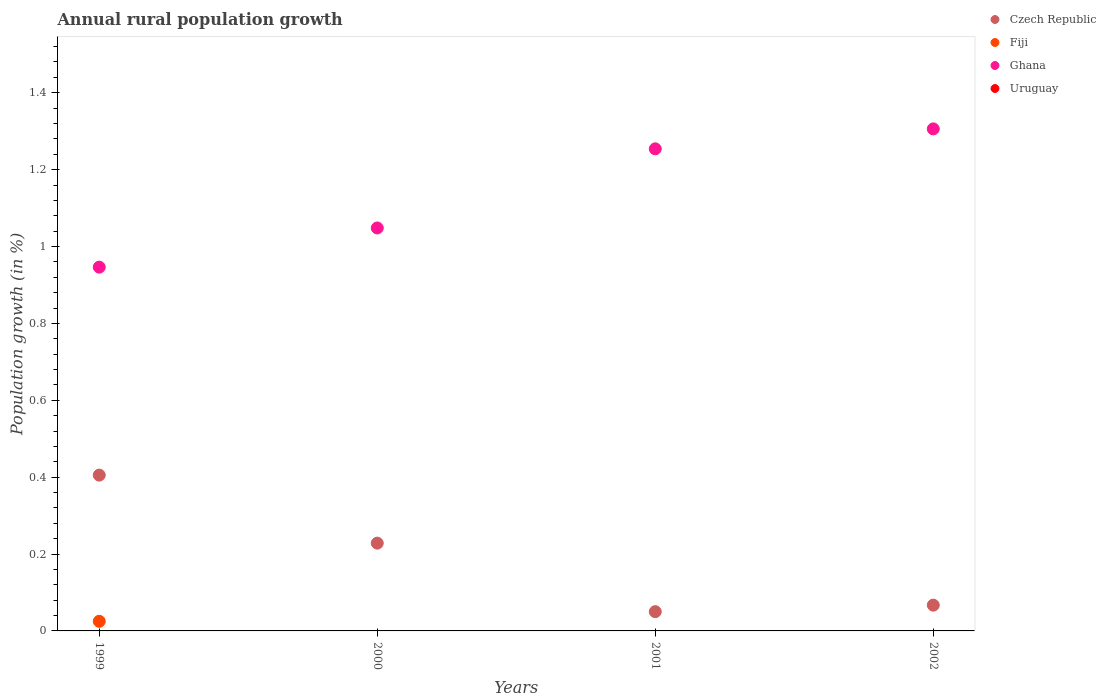Is the number of dotlines equal to the number of legend labels?
Ensure brevity in your answer.  No. What is the percentage of rural population growth in Fiji in 1999?
Provide a short and direct response. 0.03. Across all years, what is the maximum percentage of rural population growth in Ghana?
Your answer should be compact. 1.31. In which year was the percentage of rural population growth in Fiji maximum?
Provide a succinct answer. 1999. What is the total percentage of rural population growth in Fiji in the graph?
Offer a terse response. 0.03. What is the difference between the percentage of rural population growth in Czech Republic in 1999 and that in 2000?
Offer a terse response. 0.18. What is the difference between the percentage of rural population growth in Uruguay in 2001 and the percentage of rural population growth in Ghana in 2000?
Provide a succinct answer. -1.05. What is the average percentage of rural population growth in Fiji per year?
Ensure brevity in your answer.  0.01. In the year 1999, what is the difference between the percentage of rural population growth in Czech Republic and percentage of rural population growth in Ghana?
Give a very brief answer. -0.54. What is the ratio of the percentage of rural population growth in Czech Republic in 1999 to that in 2001?
Offer a very short reply. 8.09. Is the percentage of rural population growth in Czech Republic in 2000 less than that in 2002?
Keep it short and to the point. No. What is the difference between the highest and the second highest percentage of rural population growth in Ghana?
Provide a short and direct response. 0.05. What is the difference between the highest and the lowest percentage of rural population growth in Czech Republic?
Give a very brief answer. 0.36. In how many years, is the percentage of rural population growth in Fiji greater than the average percentage of rural population growth in Fiji taken over all years?
Your response must be concise. 1. Is the sum of the percentage of rural population growth in Ghana in 2000 and 2002 greater than the maximum percentage of rural population growth in Fiji across all years?
Your answer should be very brief. Yes. Is it the case that in every year, the sum of the percentage of rural population growth in Ghana and percentage of rural population growth in Fiji  is greater than the sum of percentage of rural population growth in Czech Republic and percentage of rural population growth in Uruguay?
Give a very brief answer. No. Does the percentage of rural population growth in Ghana monotonically increase over the years?
Keep it short and to the point. Yes. Is the percentage of rural population growth in Ghana strictly less than the percentage of rural population growth in Uruguay over the years?
Offer a very short reply. No. How many dotlines are there?
Ensure brevity in your answer.  3. How many years are there in the graph?
Provide a succinct answer. 4. Does the graph contain grids?
Offer a terse response. No. Where does the legend appear in the graph?
Ensure brevity in your answer.  Top right. How many legend labels are there?
Give a very brief answer. 4. What is the title of the graph?
Offer a very short reply. Annual rural population growth. What is the label or title of the Y-axis?
Your answer should be compact. Population growth (in %). What is the Population growth (in %) in Czech Republic in 1999?
Offer a very short reply. 0.41. What is the Population growth (in %) in Fiji in 1999?
Provide a succinct answer. 0.03. What is the Population growth (in %) in Ghana in 1999?
Provide a succinct answer. 0.95. What is the Population growth (in %) of Czech Republic in 2000?
Keep it short and to the point. 0.23. What is the Population growth (in %) of Fiji in 2000?
Ensure brevity in your answer.  0. What is the Population growth (in %) of Ghana in 2000?
Your response must be concise. 1.05. What is the Population growth (in %) of Uruguay in 2000?
Give a very brief answer. 0. What is the Population growth (in %) of Czech Republic in 2001?
Offer a terse response. 0.05. What is the Population growth (in %) of Fiji in 2001?
Give a very brief answer. 0. What is the Population growth (in %) in Ghana in 2001?
Your response must be concise. 1.25. What is the Population growth (in %) in Czech Republic in 2002?
Keep it short and to the point. 0.07. What is the Population growth (in %) in Ghana in 2002?
Your answer should be very brief. 1.31. What is the Population growth (in %) of Uruguay in 2002?
Your answer should be very brief. 0. Across all years, what is the maximum Population growth (in %) in Czech Republic?
Your answer should be compact. 0.41. Across all years, what is the maximum Population growth (in %) in Fiji?
Make the answer very short. 0.03. Across all years, what is the maximum Population growth (in %) of Ghana?
Your answer should be compact. 1.31. Across all years, what is the minimum Population growth (in %) of Czech Republic?
Offer a very short reply. 0.05. Across all years, what is the minimum Population growth (in %) in Ghana?
Ensure brevity in your answer.  0.95. What is the total Population growth (in %) of Czech Republic in the graph?
Keep it short and to the point. 0.75. What is the total Population growth (in %) of Fiji in the graph?
Ensure brevity in your answer.  0.03. What is the total Population growth (in %) in Ghana in the graph?
Give a very brief answer. 4.55. What is the difference between the Population growth (in %) of Czech Republic in 1999 and that in 2000?
Give a very brief answer. 0.18. What is the difference between the Population growth (in %) in Ghana in 1999 and that in 2000?
Make the answer very short. -0.1. What is the difference between the Population growth (in %) of Czech Republic in 1999 and that in 2001?
Give a very brief answer. 0.36. What is the difference between the Population growth (in %) in Ghana in 1999 and that in 2001?
Ensure brevity in your answer.  -0.31. What is the difference between the Population growth (in %) in Czech Republic in 1999 and that in 2002?
Provide a succinct answer. 0.34. What is the difference between the Population growth (in %) in Ghana in 1999 and that in 2002?
Provide a succinct answer. -0.36. What is the difference between the Population growth (in %) of Czech Republic in 2000 and that in 2001?
Your answer should be very brief. 0.18. What is the difference between the Population growth (in %) of Ghana in 2000 and that in 2001?
Provide a succinct answer. -0.21. What is the difference between the Population growth (in %) in Czech Republic in 2000 and that in 2002?
Your answer should be compact. 0.16. What is the difference between the Population growth (in %) of Ghana in 2000 and that in 2002?
Ensure brevity in your answer.  -0.26. What is the difference between the Population growth (in %) of Czech Republic in 2001 and that in 2002?
Give a very brief answer. -0.02. What is the difference between the Population growth (in %) of Ghana in 2001 and that in 2002?
Your answer should be compact. -0.05. What is the difference between the Population growth (in %) of Czech Republic in 1999 and the Population growth (in %) of Ghana in 2000?
Keep it short and to the point. -0.64. What is the difference between the Population growth (in %) of Fiji in 1999 and the Population growth (in %) of Ghana in 2000?
Give a very brief answer. -1.02. What is the difference between the Population growth (in %) in Czech Republic in 1999 and the Population growth (in %) in Ghana in 2001?
Provide a short and direct response. -0.85. What is the difference between the Population growth (in %) of Fiji in 1999 and the Population growth (in %) of Ghana in 2001?
Ensure brevity in your answer.  -1.23. What is the difference between the Population growth (in %) in Czech Republic in 1999 and the Population growth (in %) in Ghana in 2002?
Your answer should be compact. -0.9. What is the difference between the Population growth (in %) in Fiji in 1999 and the Population growth (in %) in Ghana in 2002?
Make the answer very short. -1.28. What is the difference between the Population growth (in %) of Czech Republic in 2000 and the Population growth (in %) of Ghana in 2001?
Keep it short and to the point. -1.03. What is the difference between the Population growth (in %) of Czech Republic in 2000 and the Population growth (in %) of Ghana in 2002?
Provide a succinct answer. -1.08. What is the difference between the Population growth (in %) of Czech Republic in 2001 and the Population growth (in %) of Ghana in 2002?
Keep it short and to the point. -1.26. What is the average Population growth (in %) in Czech Republic per year?
Make the answer very short. 0.19. What is the average Population growth (in %) of Fiji per year?
Provide a succinct answer. 0.01. What is the average Population growth (in %) of Ghana per year?
Make the answer very short. 1.14. In the year 1999, what is the difference between the Population growth (in %) in Czech Republic and Population growth (in %) in Fiji?
Give a very brief answer. 0.38. In the year 1999, what is the difference between the Population growth (in %) in Czech Republic and Population growth (in %) in Ghana?
Your answer should be very brief. -0.54. In the year 1999, what is the difference between the Population growth (in %) of Fiji and Population growth (in %) of Ghana?
Provide a succinct answer. -0.92. In the year 2000, what is the difference between the Population growth (in %) in Czech Republic and Population growth (in %) in Ghana?
Offer a very short reply. -0.82. In the year 2001, what is the difference between the Population growth (in %) of Czech Republic and Population growth (in %) of Ghana?
Give a very brief answer. -1.2. In the year 2002, what is the difference between the Population growth (in %) in Czech Republic and Population growth (in %) in Ghana?
Provide a succinct answer. -1.24. What is the ratio of the Population growth (in %) in Czech Republic in 1999 to that in 2000?
Your answer should be very brief. 1.77. What is the ratio of the Population growth (in %) in Ghana in 1999 to that in 2000?
Provide a short and direct response. 0.9. What is the ratio of the Population growth (in %) in Czech Republic in 1999 to that in 2001?
Your response must be concise. 8.09. What is the ratio of the Population growth (in %) of Ghana in 1999 to that in 2001?
Ensure brevity in your answer.  0.75. What is the ratio of the Population growth (in %) of Czech Republic in 1999 to that in 2002?
Keep it short and to the point. 6.04. What is the ratio of the Population growth (in %) of Ghana in 1999 to that in 2002?
Provide a succinct answer. 0.72. What is the ratio of the Population growth (in %) of Czech Republic in 2000 to that in 2001?
Your answer should be very brief. 4.56. What is the ratio of the Population growth (in %) in Ghana in 2000 to that in 2001?
Make the answer very short. 0.84. What is the ratio of the Population growth (in %) of Czech Republic in 2000 to that in 2002?
Ensure brevity in your answer.  3.41. What is the ratio of the Population growth (in %) of Ghana in 2000 to that in 2002?
Your answer should be very brief. 0.8. What is the ratio of the Population growth (in %) of Czech Republic in 2001 to that in 2002?
Ensure brevity in your answer.  0.75. What is the ratio of the Population growth (in %) in Ghana in 2001 to that in 2002?
Keep it short and to the point. 0.96. What is the difference between the highest and the second highest Population growth (in %) in Czech Republic?
Give a very brief answer. 0.18. What is the difference between the highest and the second highest Population growth (in %) of Ghana?
Provide a short and direct response. 0.05. What is the difference between the highest and the lowest Population growth (in %) of Czech Republic?
Your response must be concise. 0.36. What is the difference between the highest and the lowest Population growth (in %) of Fiji?
Make the answer very short. 0.03. What is the difference between the highest and the lowest Population growth (in %) in Ghana?
Keep it short and to the point. 0.36. 